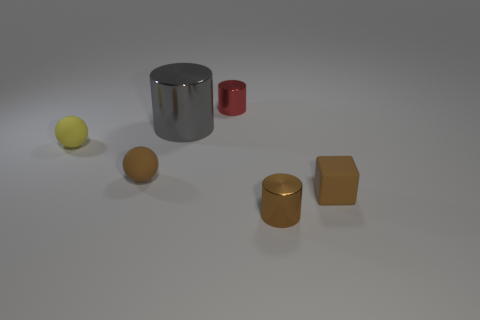Subtract all small cylinders. How many cylinders are left? 1 Add 3 gray things. How many objects exist? 9 Subtract all blocks. How many objects are left? 5 Add 5 matte things. How many matte things are left? 8 Add 5 small red objects. How many small red objects exist? 6 Subtract 1 gray cylinders. How many objects are left? 5 Subtract all yellow rubber objects. Subtract all small red cylinders. How many objects are left? 4 